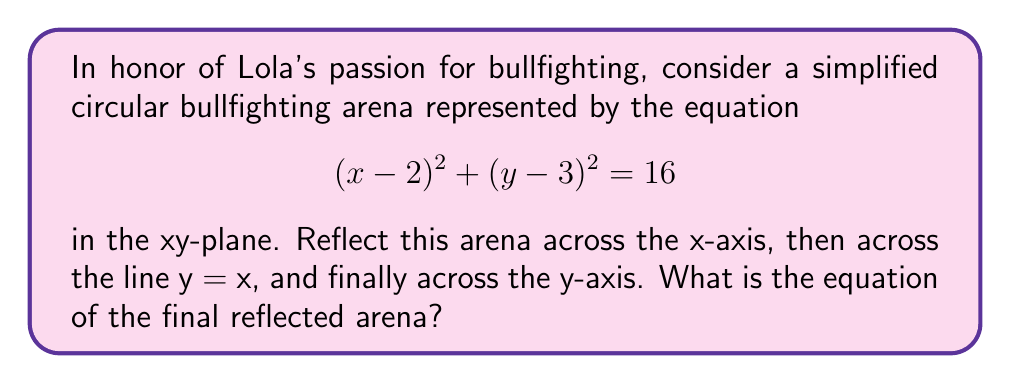Teach me how to tackle this problem. Let's approach this step-by-step:

1) First reflection across the x-axis:
   - This changes the sign of y coordinates.
   - The equation becomes: $$(x-2)^2 + (-y-3)^2 = 16$$
   - Simplifying: $$(x-2)^2 + (y+3)^2 = 16$$

2) Next, reflection across y = x:
   - This swaps x and y coordinates.
   - The equation becomes: $$(y-2)^2 + (x+3)^2 = 16$$

3) Finally, reflection across the y-axis:
   - This changes the sign of x coordinates.
   - The equation becomes: $$(-y-2)^2 + (x+3)^2 = 16$$
   - Simplifying: $$(y+2)^2 + (x+3)^2 = 16$$

4) To get the standard form, let's expand:
   $$y^2 + 4y + 4 + x^2 + 6x + 9 = 16$$
   $$x^2 + y^2 + 6x + 4y - 3 = 0$$

5) Completing the square for both x and y:
   $$(x^2 + 6x + 9) + (y^2 + 4y + 4) = 16$$
   $$(x+3)^2 + (y+2)^2 = 16$$

Therefore, the final equation of the reflected arena is $(x+3)^2 + (y+2)^2 = 16$.
Answer: $(x+3)^2 + (y+2)^2 = 16$ 